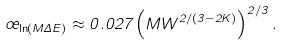Convert formula to latex. <formula><loc_0><loc_0><loc_500><loc_500>\sigma _ { \ln ( M \Delta E ) } \approx 0 . 0 2 7 \left ( M W ^ { 2 / ( 3 - 2 K ) } \right ) ^ { 2 / 3 } .</formula> 